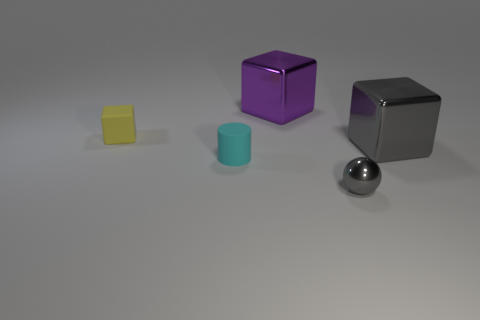Subtract all tiny cubes. How many cubes are left? 2 Add 3 gray objects. How many objects exist? 8 Subtract all cylinders. How many objects are left? 4 Subtract all red blocks. Subtract all yellow cylinders. How many blocks are left? 3 Subtract 0 yellow balls. How many objects are left? 5 Subtract all large blue things. Subtract all big gray metal objects. How many objects are left? 4 Add 3 purple shiny things. How many purple shiny things are left? 4 Add 3 big purple metallic cubes. How many big purple metallic cubes exist? 4 